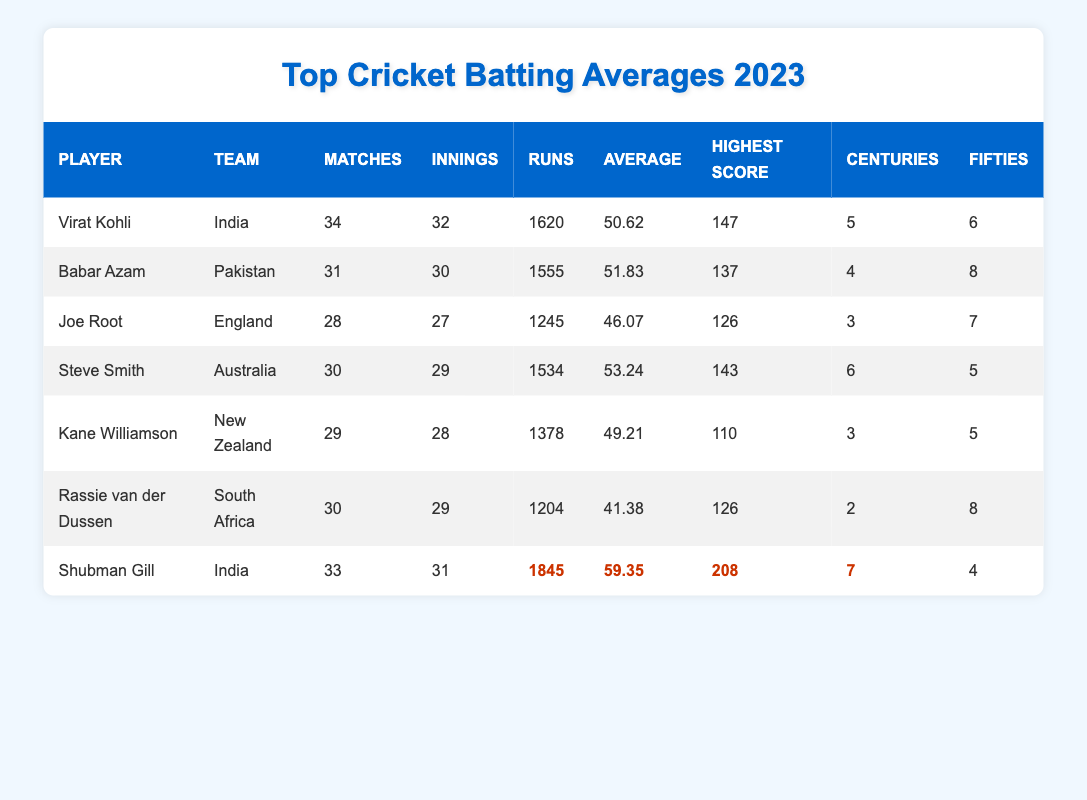What is the highest batting average among the players listed in the table? Shubman Gill has the highest average of 59.35 as indicated in the average column.
Answer: 59.35 How many matches did Virat Kohli play in 2023? The table states that Virat Kohli played 34 matches in 2023, as shown in the matches column.
Answer: 34 Who scored the most runs according to the table? Shubman Gill scored the most runs with a total of 1845 runs, which can be found in the runs column.
Answer: 1845 Which player has the highest score in an inning? The highest score in an inning is 208 by Shubman Gill, listed under the highest score column.
Answer: 208 How many centuries did Babar Azam score in 2023? Babar Azam scored 4 centuries, as indicated in the centuries column for him.
Answer: 4 Which player has the lowest batting average? Rassie van der Dussen has the lowest batting average of 41.38, as seen in the average column.
Answer: 41.38 If we consider only the players from India, what is their combined total of fifties? Both Virat Kohli and Shubman Gill scored a total of 10 fifties (6 + 4) when combining their fifties from the fifties column.
Answer: 10 How many more centuries did Steve Smith score compared to Joe Root? Steve Smith scored 6 centuries while Joe Root scored 3 centuries, so the difference is 6 - 3 = 3 centuries more.
Answer: 3 Is it true that Kane Williamson had a higher average than Joe Root? Yes, as Kane Williamson's average is 49.21 while Joe Root's average is 46.07, indicating that Kane Williamson has a higher average.
Answer: Yes Which player, among those listed, has the most fifties in 2023? Babar Azam scored the most fifties with a total of 8, as pointed out in the fifties column.
Answer: 8 If we calculate the average runs scored by the players, what would that be approximately? To find the average, we add the runs: (1620 + 1555 + 1245 + 1534 + 1378 + 1204 + 1845) = 10381; divided by the total number of players (7) gives approximately 1483.14.
Answer: Approximately 1483.14 How many total matches did the players from India play combined? Virat Kohli (34 matches) and Shubman Gill (33 matches) played a combined total of 67 matches (34 + 33).
Answer: 67 